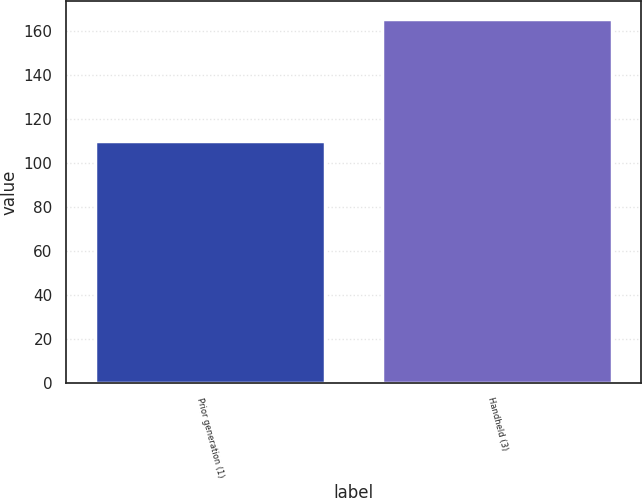<chart> <loc_0><loc_0><loc_500><loc_500><bar_chart><fcel>Prior generation (1)<fcel>Handheld (3)<nl><fcel>110.1<fcel>165.3<nl></chart> 